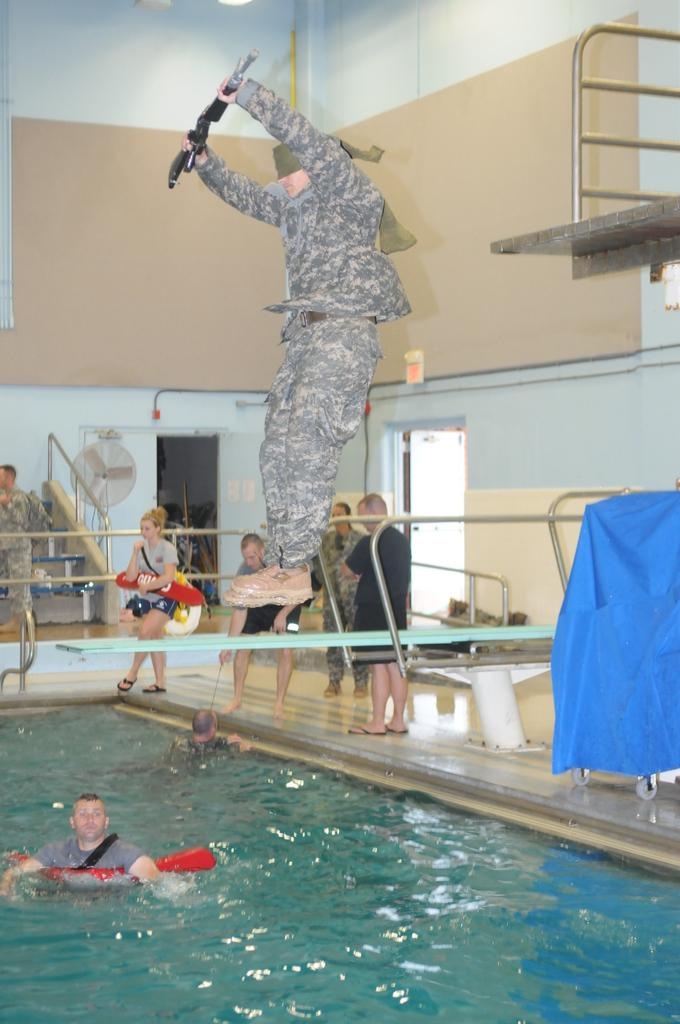What is the main feature of the image? There is a swimming pool in the picture. What can be seen inside the swimming pool? There are people in the swimming pool. What type of substance is being used to clean the tub in the image? There is no tub present in the image, and therefore no cleaning substance can be observed. 